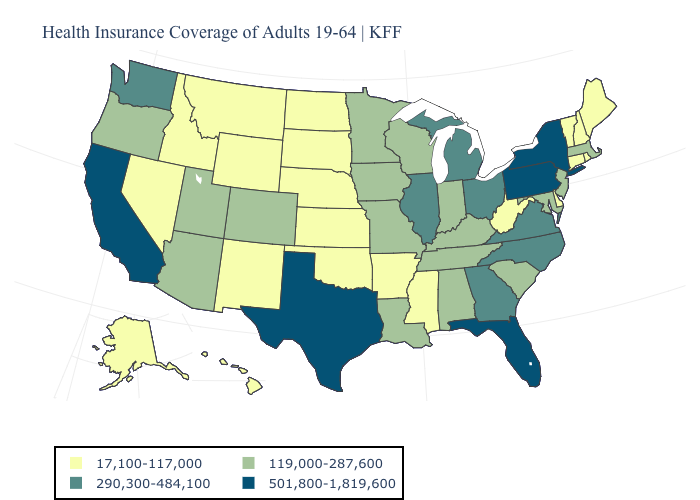What is the value of Massachusetts?
Answer briefly. 119,000-287,600. How many symbols are there in the legend?
Write a very short answer. 4. Does New Jersey have a higher value than Louisiana?
Be succinct. No. Among the states that border Nebraska , does Colorado have the lowest value?
Write a very short answer. No. What is the value of Nebraska?
Answer briefly. 17,100-117,000. What is the value of Hawaii?
Be succinct. 17,100-117,000. Name the states that have a value in the range 290,300-484,100?
Answer briefly. Georgia, Illinois, Michigan, North Carolina, Ohio, Virginia, Washington. Which states have the highest value in the USA?
Be succinct. California, Florida, New York, Pennsylvania, Texas. Name the states that have a value in the range 119,000-287,600?
Be succinct. Alabama, Arizona, Colorado, Indiana, Iowa, Kentucky, Louisiana, Maryland, Massachusetts, Minnesota, Missouri, New Jersey, Oregon, South Carolina, Tennessee, Utah, Wisconsin. What is the value of Virginia?
Short answer required. 290,300-484,100. Among the states that border Texas , which have the lowest value?
Be succinct. Arkansas, New Mexico, Oklahoma. Which states have the lowest value in the Northeast?
Write a very short answer. Connecticut, Maine, New Hampshire, Rhode Island, Vermont. How many symbols are there in the legend?
Be succinct. 4. Name the states that have a value in the range 17,100-117,000?
Keep it brief. Alaska, Arkansas, Connecticut, Delaware, Hawaii, Idaho, Kansas, Maine, Mississippi, Montana, Nebraska, Nevada, New Hampshire, New Mexico, North Dakota, Oklahoma, Rhode Island, South Dakota, Vermont, West Virginia, Wyoming. What is the value of Wyoming?
Short answer required. 17,100-117,000. 